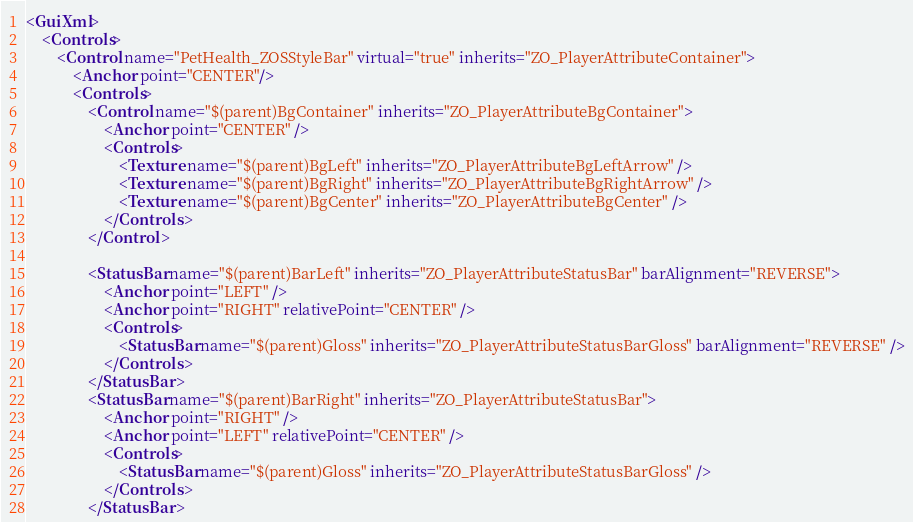<code> <loc_0><loc_0><loc_500><loc_500><_XML_><GuiXml>
	<Controls>
		<Control name="PetHealth_ZOSStyleBar" virtual="true" inherits="ZO_PlayerAttributeContainer">
            <Anchor point="CENTER"/>
            <Controls>
                <Control name="$(parent)BgContainer" inherits="ZO_PlayerAttributeBgContainer">
                    <Anchor point="CENTER" />
                    <Controls>
                        <Texture name="$(parent)BgLeft" inherits="ZO_PlayerAttributeBgLeftArrow" />
                        <Texture name="$(parent)BgRight" inherits="ZO_PlayerAttributeBgRightArrow" />
                        <Texture name="$(parent)BgCenter" inherits="ZO_PlayerAttributeBgCenter" />
                    </Controls>
                </Control>
                
                <StatusBar name="$(parent)BarLeft" inherits="ZO_PlayerAttributeStatusBar" barAlignment="REVERSE">
                    <Anchor point="LEFT" />
                    <Anchor point="RIGHT" relativePoint="CENTER" />
                    <Controls>
                        <StatusBar name="$(parent)Gloss" inherits="ZO_PlayerAttributeStatusBarGloss" barAlignment="REVERSE" />
                    </Controls>
                </StatusBar>
                <StatusBar name="$(parent)BarRight" inherits="ZO_PlayerAttributeStatusBar">
                    <Anchor point="RIGHT" />
                    <Anchor point="LEFT" relativePoint="CENTER" />
                    <Controls>
                        <StatusBar name="$(parent)Gloss" inherits="ZO_PlayerAttributeStatusBarGloss" />
                    </Controls>
                </StatusBar>
</code> 